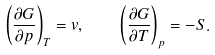<formula> <loc_0><loc_0><loc_500><loc_500>\left ( \frac { \partial G } { \partial p } \right ) _ { T } = v , \quad \left ( \frac { \partial G } { \partial T } \right ) _ { p } = - S .</formula> 